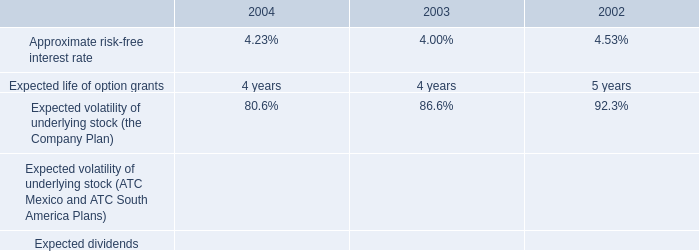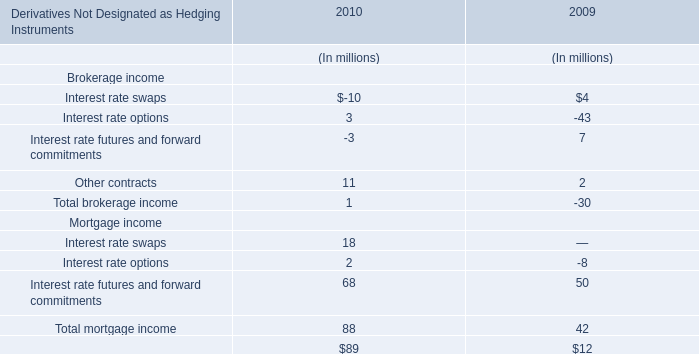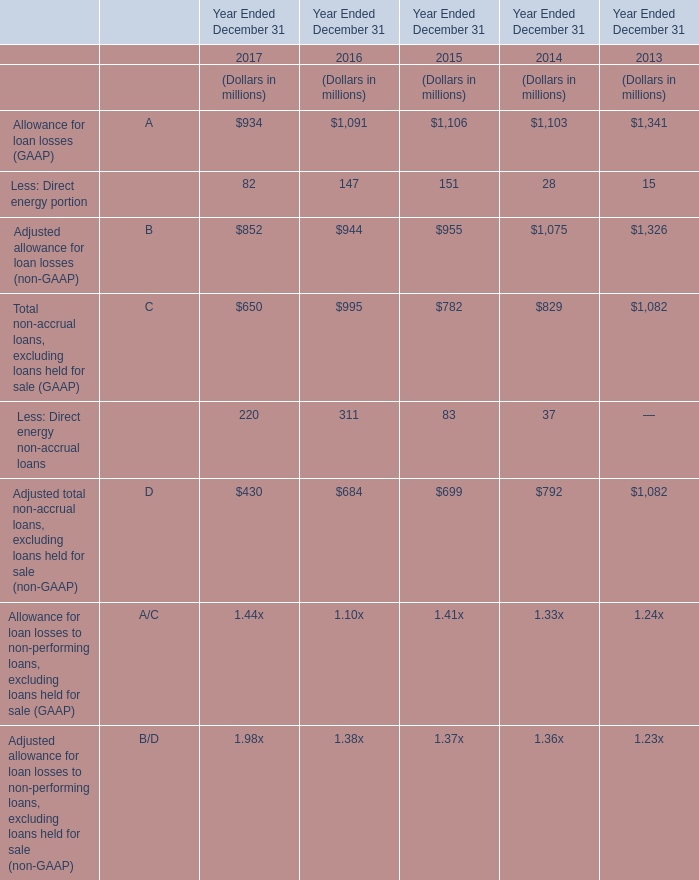What is the average value of Less: Direct energy non-accrual loans in 2017,2016 and 2015? (in million) 
Computations: (((220 + 311) + 83) / 3)
Answer: 204.66667. 